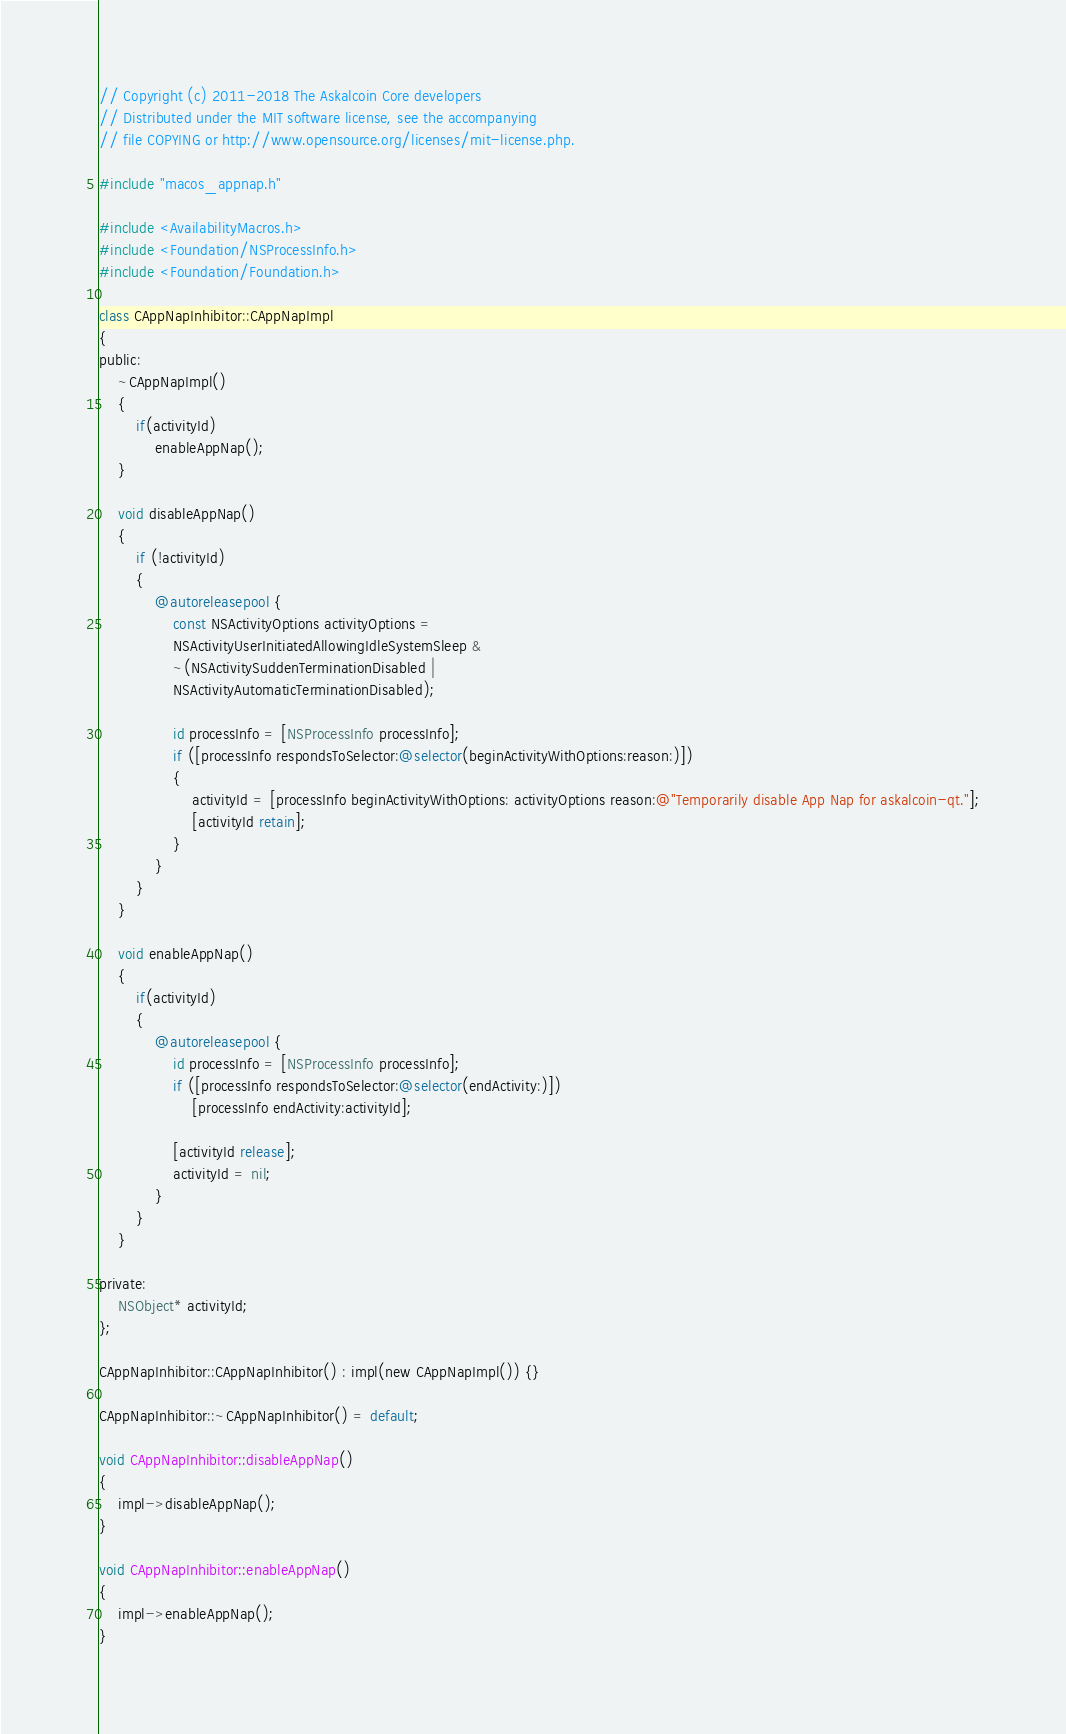<code> <loc_0><loc_0><loc_500><loc_500><_ObjectiveC_>// Copyright (c) 2011-2018 The Askalcoin Core developers
// Distributed under the MIT software license, see the accompanying
// file COPYING or http://www.opensource.org/licenses/mit-license.php.

#include "macos_appnap.h"

#include <AvailabilityMacros.h>
#include <Foundation/NSProcessInfo.h>
#include <Foundation/Foundation.h>

class CAppNapInhibitor::CAppNapImpl
{
public:
    ~CAppNapImpl()
    {
        if(activityId)
            enableAppNap();
    }

    void disableAppNap()
    {
        if (!activityId)
        {
            @autoreleasepool {
                const NSActivityOptions activityOptions =
                NSActivityUserInitiatedAllowingIdleSystemSleep &
                ~(NSActivitySuddenTerminationDisabled |
                NSActivityAutomaticTerminationDisabled);

                id processInfo = [NSProcessInfo processInfo];
                if ([processInfo respondsToSelector:@selector(beginActivityWithOptions:reason:)])
                {
                    activityId = [processInfo beginActivityWithOptions: activityOptions reason:@"Temporarily disable App Nap for askalcoin-qt."];
                    [activityId retain];
                }
            }
        }
    }

    void enableAppNap()
    {
        if(activityId)
        {
            @autoreleasepool {
                id processInfo = [NSProcessInfo processInfo];
                if ([processInfo respondsToSelector:@selector(endActivity:)])
                    [processInfo endActivity:activityId];

                [activityId release];
                activityId = nil;
            }
        }
    }

private:
    NSObject* activityId;
};

CAppNapInhibitor::CAppNapInhibitor() : impl(new CAppNapImpl()) {}

CAppNapInhibitor::~CAppNapInhibitor() = default;

void CAppNapInhibitor::disableAppNap()
{
    impl->disableAppNap();
}

void CAppNapInhibitor::enableAppNap()
{
    impl->enableAppNap();
}
</code> 